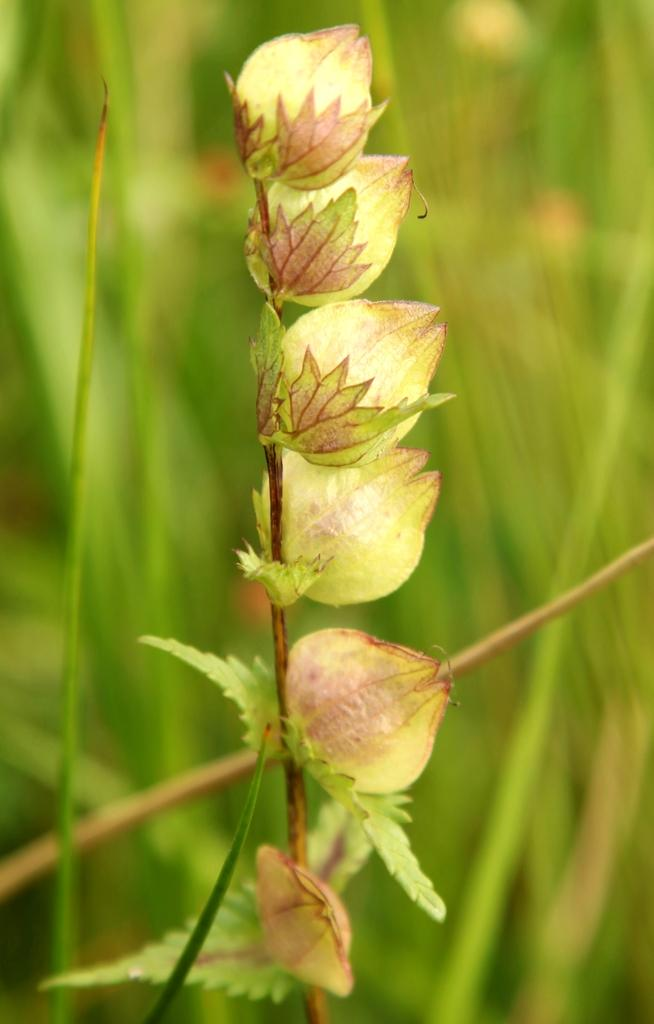What type of living organisms can be seen in the image? Plants can be seen in the image. What type of knife is being used to help put out the fire in the image? There is no knife, help, or fire present in the image; it only contains plants. 